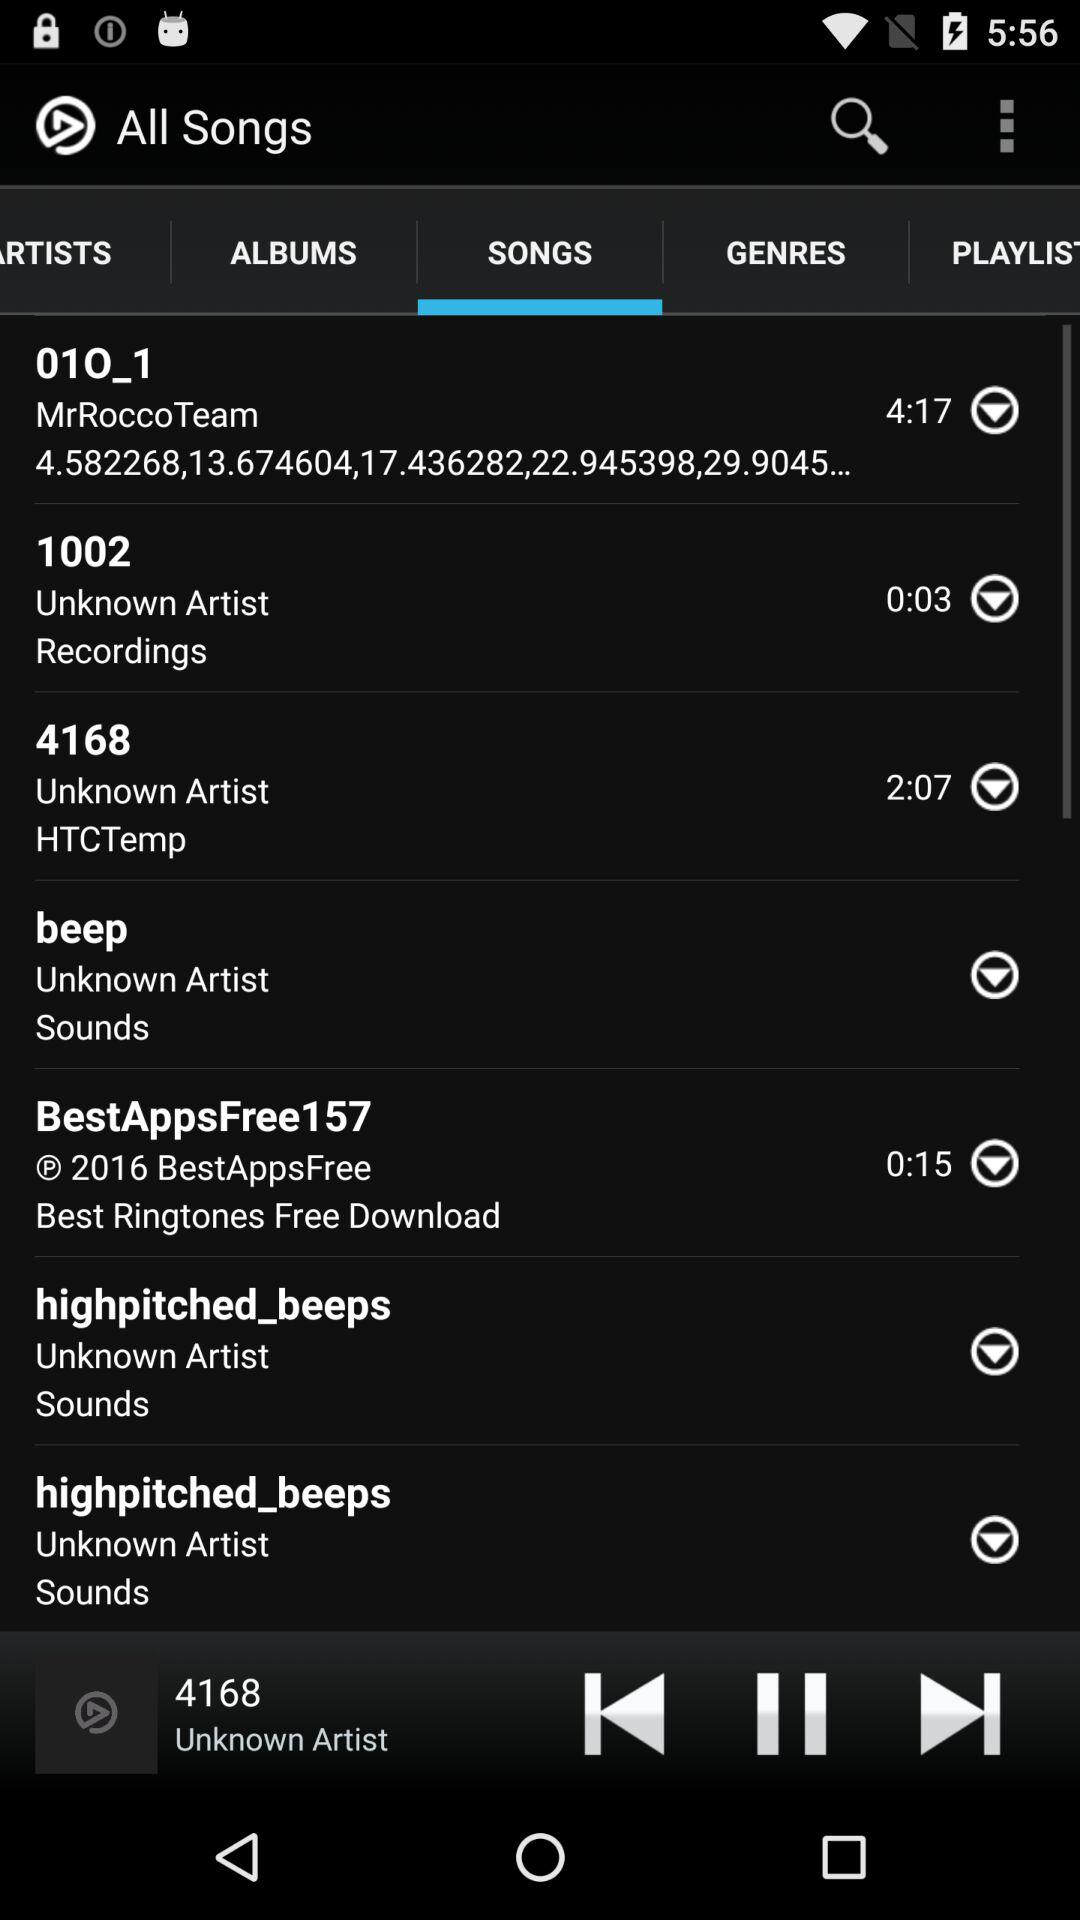Who is the artist of the song that is currently playing? The artist is unknown. 